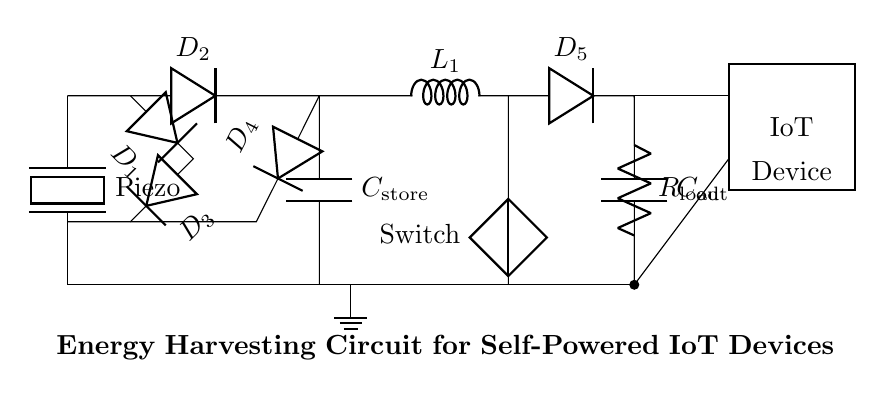What is the primary energy source for this circuit? The primary energy source indicated in the circuit is the piezoelectric sensor, which converts mechanical stress into electrical energy.
Answer: Piezoelectric sensor What are the components used in the rectifier bridge? The components used in the rectifier bridge include four diodes labeled D1, D2, D3, and D4, which are arranged to convert AC to DC.
Answer: D1, D2, D3, D4 What is the purpose of the storage capacitor? The storage capacitor, labeled C_store, is used to store the rectified voltage for supplying power to the load when the generated energy is insufficient.
Answer: C_store How many diodes are present in the circuit? There are a total of four diodes present in the circuit diagram, which are essential for the rectification process in the energy harvesting circuit.
Answer: Four What is the function of the DC-DC converter in this circuit? The DC-DC converter, which includes an inductor and a switch, regulates the output voltage to ensure it meets the voltage requirements of the IoT device.
Answer: Voltage regulation What type of load is indicated in this circuit? The load indicated in the circuit is a resistor (R_load), which represents the electrical demand of the IoT device being powered.
Answer: Resistor How does the circuit ensure that the IoT device functions continuously? The circuit uses energy harvesting from the piezoelectric sensor combined with storage in the capacitor, allowing continuous operation even when mechanical energy is limited.
Answer: Energy harvesting and storage 